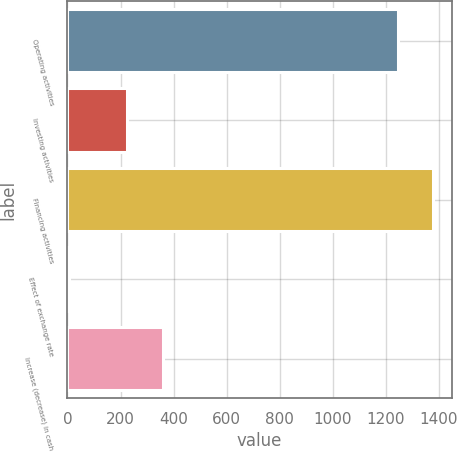Convert chart. <chart><loc_0><loc_0><loc_500><loc_500><bar_chart><fcel>Operating activities<fcel>Investing activities<fcel>Financing activities<fcel>Effect of exchange rate<fcel>Increase (decrease) in cash<nl><fcel>1246<fcel>225<fcel>1379.8<fcel>6<fcel>358.8<nl></chart> 